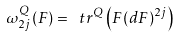Convert formula to latex. <formula><loc_0><loc_0><loc_500><loc_500>\omega ^ { Q } _ { 2 j } ( F ) = \ t r ^ { Q } \left ( F ( d F ) ^ { 2 j } \right )</formula> 